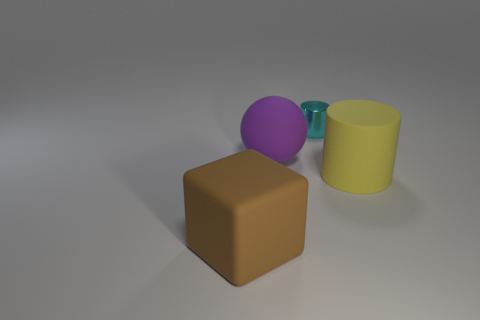Add 3 big purple cylinders. How many objects exist? 7 Subtract all balls. How many objects are left? 3 Subtract 0 cyan balls. How many objects are left? 4 Subtract all large green rubber cubes. Subtract all cyan objects. How many objects are left? 3 Add 4 rubber cylinders. How many rubber cylinders are left? 5 Add 4 yellow things. How many yellow things exist? 5 